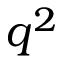<formula> <loc_0><loc_0><loc_500><loc_500>q ^ { 2 }</formula> 